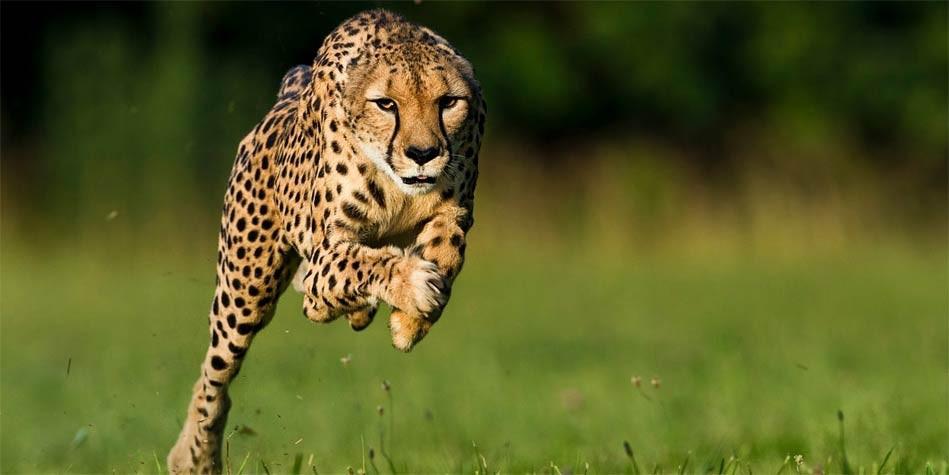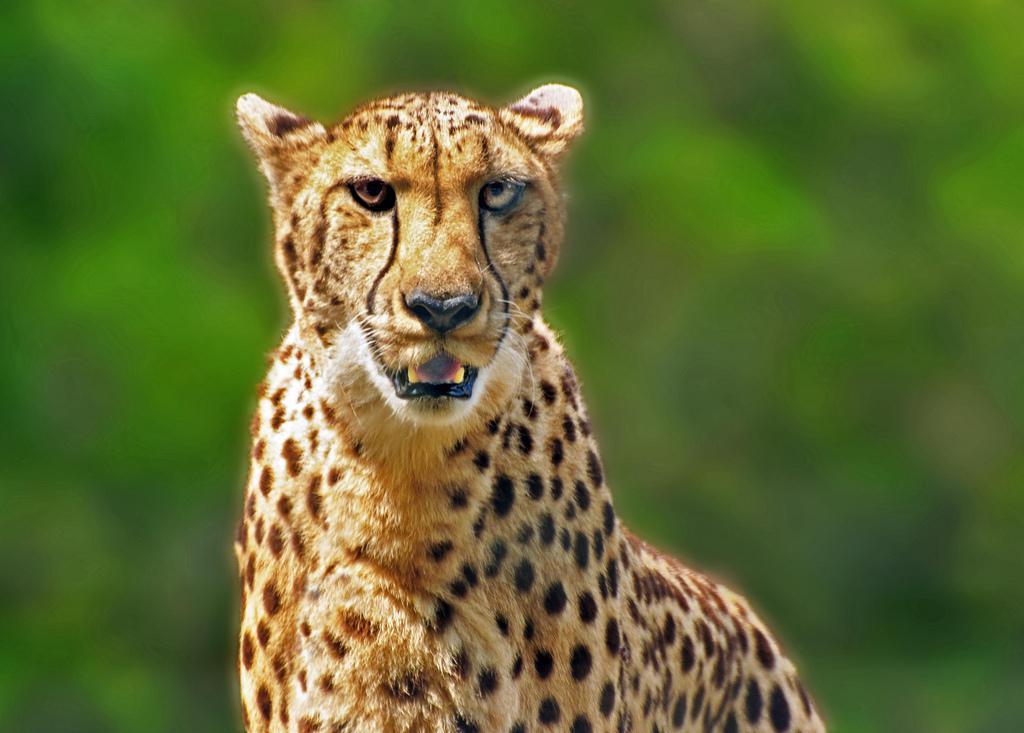The first image is the image on the left, the second image is the image on the right. Analyze the images presented: Is the assertion "A cheetah has its mouth partially open." valid? Answer yes or no. Yes. 